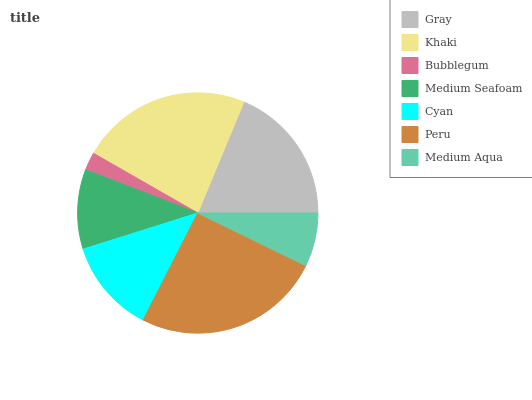Is Bubblegum the minimum?
Answer yes or no. Yes. Is Peru the maximum?
Answer yes or no. Yes. Is Khaki the minimum?
Answer yes or no. No. Is Khaki the maximum?
Answer yes or no. No. Is Khaki greater than Gray?
Answer yes or no. Yes. Is Gray less than Khaki?
Answer yes or no. Yes. Is Gray greater than Khaki?
Answer yes or no. No. Is Khaki less than Gray?
Answer yes or no. No. Is Cyan the high median?
Answer yes or no. Yes. Is Cyan the low median?
Answer yes or no. Yes. Is Gray the high median?
Answer yes or no. No. Is Peru the low median?
Answer yes or no. No. 